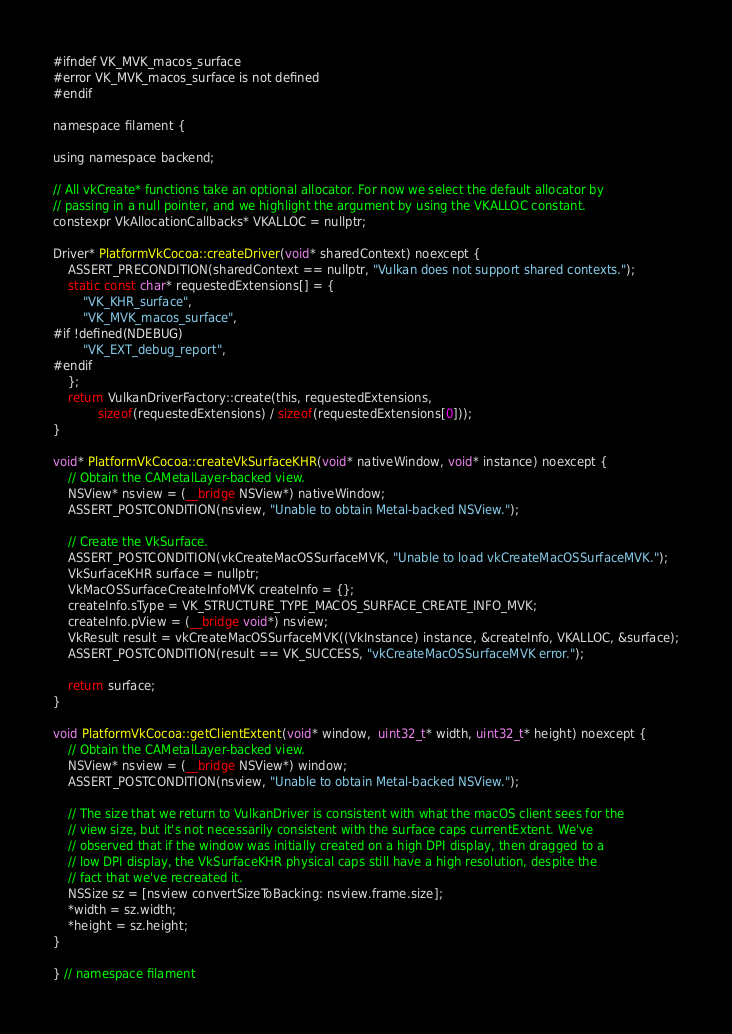Convert code to text. <code><loc_0><loc_0><loc_500><loc_500><_ObjectiveC_>
#ifndef VK_MVK_macos_surface
#error VK_MVK_macos_surface is not defined
#endif

namespace filament {

using namespace backend;

// All vkCreate* functions take an optional allocator. For now we select the default allocator by
// passing in a null pointer, and we highlight the argument by using the VKALLOC constant.
constexpr VkAllocationCallbacks* VKALLOC = nullptr;

Driver* PlatformVkCocoa::createDriver(void* sharedContext) noexcept {
    ASSERT_PRECONDITION(sharedContext == nullptr, "Vulkan does not support shared contexts.");
    static const char* requestedExtensions[] = {
        "VK_KHR_surface",
        "VK_MVK_macos_surface",
#if !defined(NDEBUG)
        "VK_EXT_debug_report",
#endif
    };
    return VulkanDriverFactory::create(this, requestedExtensions,
            sizeof(requestedExtensions) / sizeof(requestedExtensions[0]));
}

void* PlatformVkCocoa::createVkSurfaceKHR(void* nativeWindow, void* instance) noexcept {
    // Obtain the CAMetalLayer-backed view.
    NSView* nsview = (__bridge NSView*) nativeWindow;
    ASSERT_POSTCONDITION(nsview, "Unable to obtain Metal-backed NSView.");

    // Create the VkSurface.
    ASSERT_POSTCONDITION(vkCreateMacOSSurfaceMVK, "Unable to load vkCreateMacOSSurfaceMVK.");
    VkSurfaceKHR surface = nullptr;
    VkMacOSSurfaceCreateInfoMVK createInfo = {};
    createInfo.sType = VK_STRUCTURE_TYPE_MACOS_SURFACE_CREATE_INFO_MVK;
    createInfo.pView = (__bridge void*) nsview;
    VkResult result = vkCreateMacOSSurfaceMVK((VkInstance) instance, &createInfo, VKALLOC, &surface);
    ASSERT_POSTCONDITION(result == VK_SUCCESS, "vkCreateMacOSSurfaceMVK error.");

    return surface;
}

void PlatformVkCocoa::getClientExtent(void* window,  uint32_t* width, uint32_t* height) noexcept {
    // Obtain the CAMetalLayer-backed view.
    NSView* nsview = (__bridge NSView*) window;
    ASSERT_POSTCONDITION(nsview, "Unable to obtain Metal-backed NSView.");

    // The size that we return to VulkanDriver is consistent with what the macOS client sees for the
    // view size, but it's not necessarily consistent with the surface caps currentExtent. We've
    // observed that if the window was initially created on a high DPI display, then dragged to a
    // low DPI display, the VkSurfaceKHR physical caps still have a high resolution, despite the
    // fact that we've recreated it.
    NSSize sz = [nsview convertSizeToBacking: nsview.frame.size];
    *width = sz.width;
    *height = sz.height;
}

} // namespace filament
</code> 